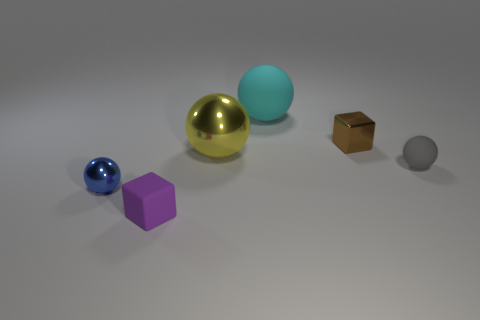There is a brown shiny thing; does it have the same size as the blue sphere left of the big cyan sphere?
Provide a short and direct response. Yes. Are there any other things that have the same shape as the cyan thing?
Offer a terse response. Yes. There is another big matte thing that is the same shape as the gray matte thing; what is its color?
Provide a succinct answer. Cyan. Is the size of the purple rubber object the same as the blue thing?
Your answer should be very brief. Yes. What number of other things are the same size as the purple cube?
Provide a succinct answer. 3. How many things are small rubber objects to the right of the cyan rubber thing or small things that are to the right of the blue thing?
Provide a succinct answer. 3. The gray object that is the same size as the matte block is what shape?
Provide a short and direct response. Sphere. There is a block that is made of the same material as the tiny blue thing; what is its size?
Provide a succinct answer. Small. Do the cyan object and the large yellow metallic thing have the same shape?
Offer a terse response. Yes. There is a metal cube that is the same size as the gray thing; what is its color?
Your answer should be very brief. Brown. 